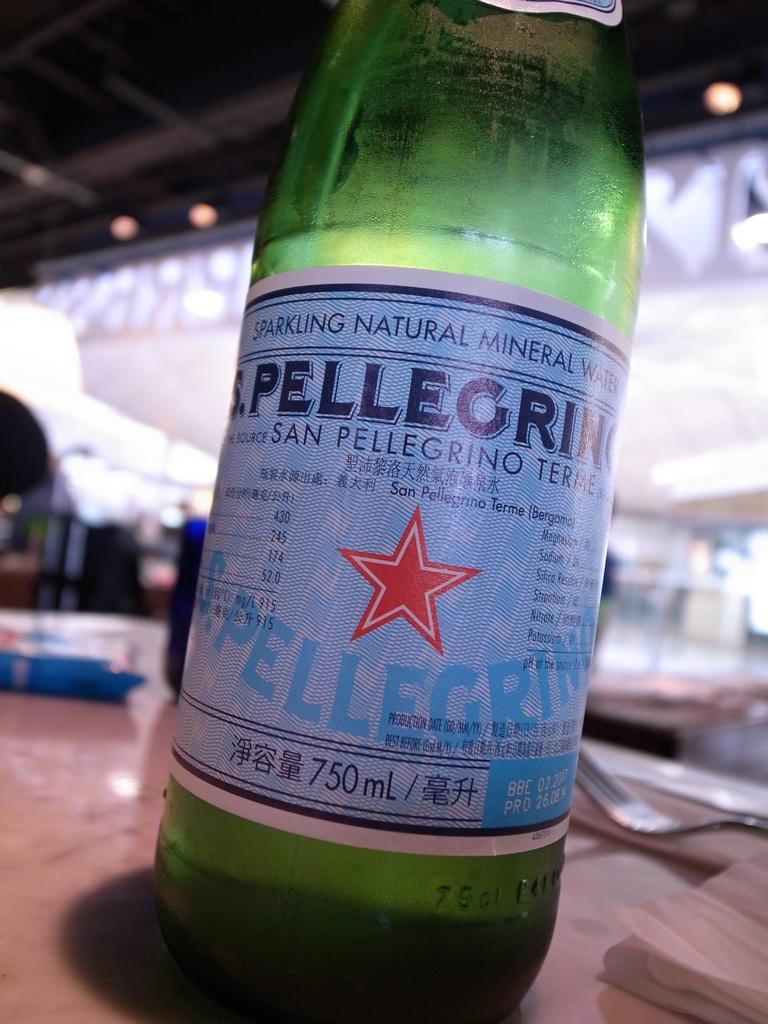What brand of water is this?
Provide a short and direct response. Pellegrino. 